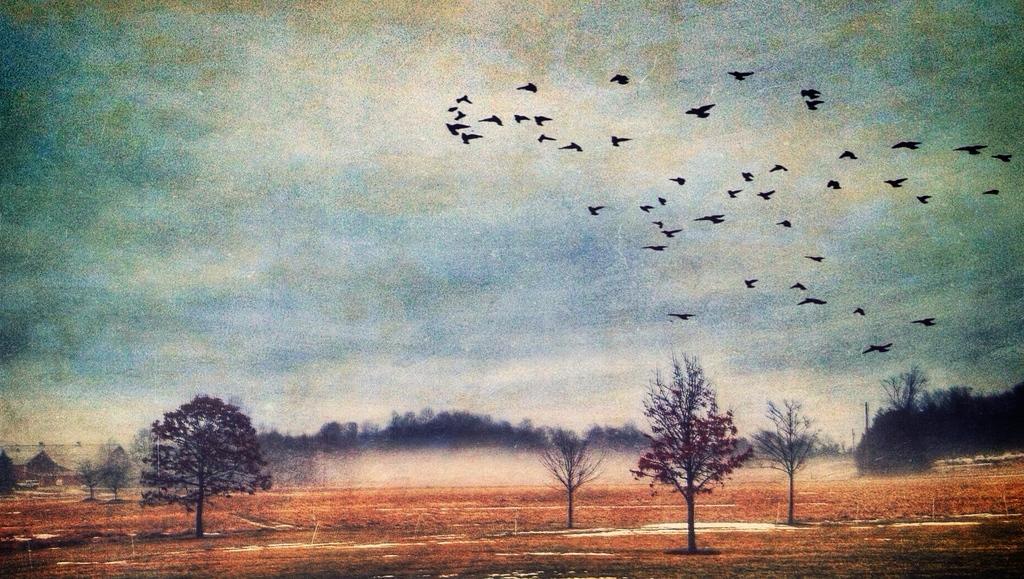Could you give a brief overview of what you see in this image? In this image we can see trees, birds. In the background of the image there is sky and clouds. At the bottom of the image there is dry grass. 